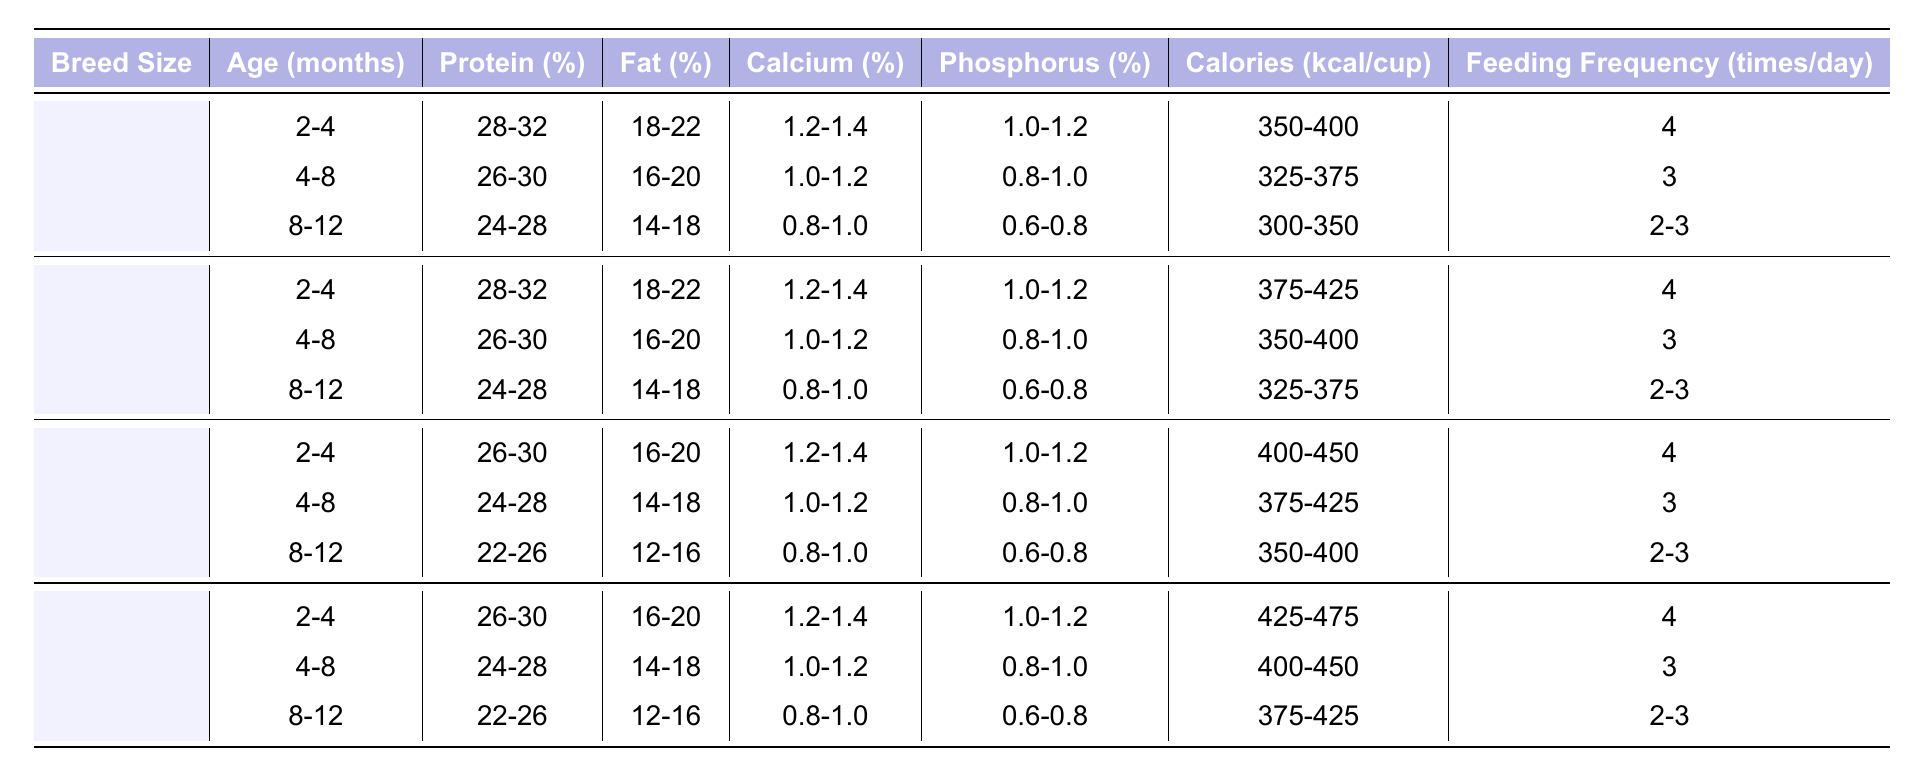What is the protein percentage for small breed puppies aged 2-4 months? According to the table, the protein percentage for small breed puppies aged 2-4 months falls between 28-32%.
Answer: 28-32% How many times a day should medium breed puppies be fed at 4-8 months old? The table indicates that medium breed puppies at 4-8 months old should be fed 3 times a day.
Answer: 3 Does large breed puppy food contain more fat than small breed puppy food at 8-12 months? By comparing the fat percentages for large breed (12-16%) and small breed puppies (14-18%) at 8-12 months, it shows that small breed puppy food has a higher fat content. Thus, the statement is false.
Answer: No What is the average calorie content for giant breed puppies aged 2-4 months? The table shows the calorie content for giant breed puppies aged 2-4 months ranges from 425-475 kcal/cup. The average can be calculated as (425 + 475) / 2 = 450.
Answer: 450 For which age group do small breed puppies have the highest protein percentage? Observing the table, small breed puppies aged 2-4 months have the highest protein percentage at 28-32%.
Answer: 2-4 months What is the difference in calcium percentage between medium breed puppies at 2-4 and 8-12 months? The calcium percentage for medium breed puppies at 2-4 months is 1.2-1.4% and at 8-12 months is 0.8-1.0%. The difference is calculated by taking the lower bound of each range (1.2 - 0.8 = 0.4) and the higher bound (1.4 - 1.0 = 0.4), indicating a consistent difference of 0.4%.
Answer: 0.4% Are the phosphorus percentages for large breed puppies consistent across all age groups? When checking the phosphorus percentages for large breed puppies, we see that they range from 1.0-1.2% for 2-4 months, 0.8-1.0% for 4-8 months, and 0.6-0.8% for 8-12 months, indicating they are not consistent.
Answer: No What is the feeding frequency for giant breed puppies aged 4-8 months compared to those aged 2-4 months? The feeding frequency for giant breed puppies at 4-8 months is 3 times a day, while at 2-4 months, it is 4 times a day. Therefore, there is a decrease of 1 feeding frequency.
Answer: 1 less feeding frequency 